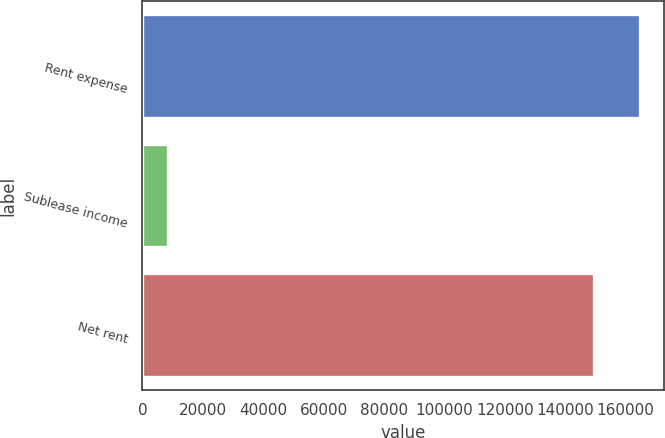<chart> <loc_0><loc_0><loc_500><loc_500><bar_chart><fcel>Rent expense<fcel>Sublease income<fcel>Net rent<nl><fcel>164604<fcel>8315<fcel>149640<nl></chart> 